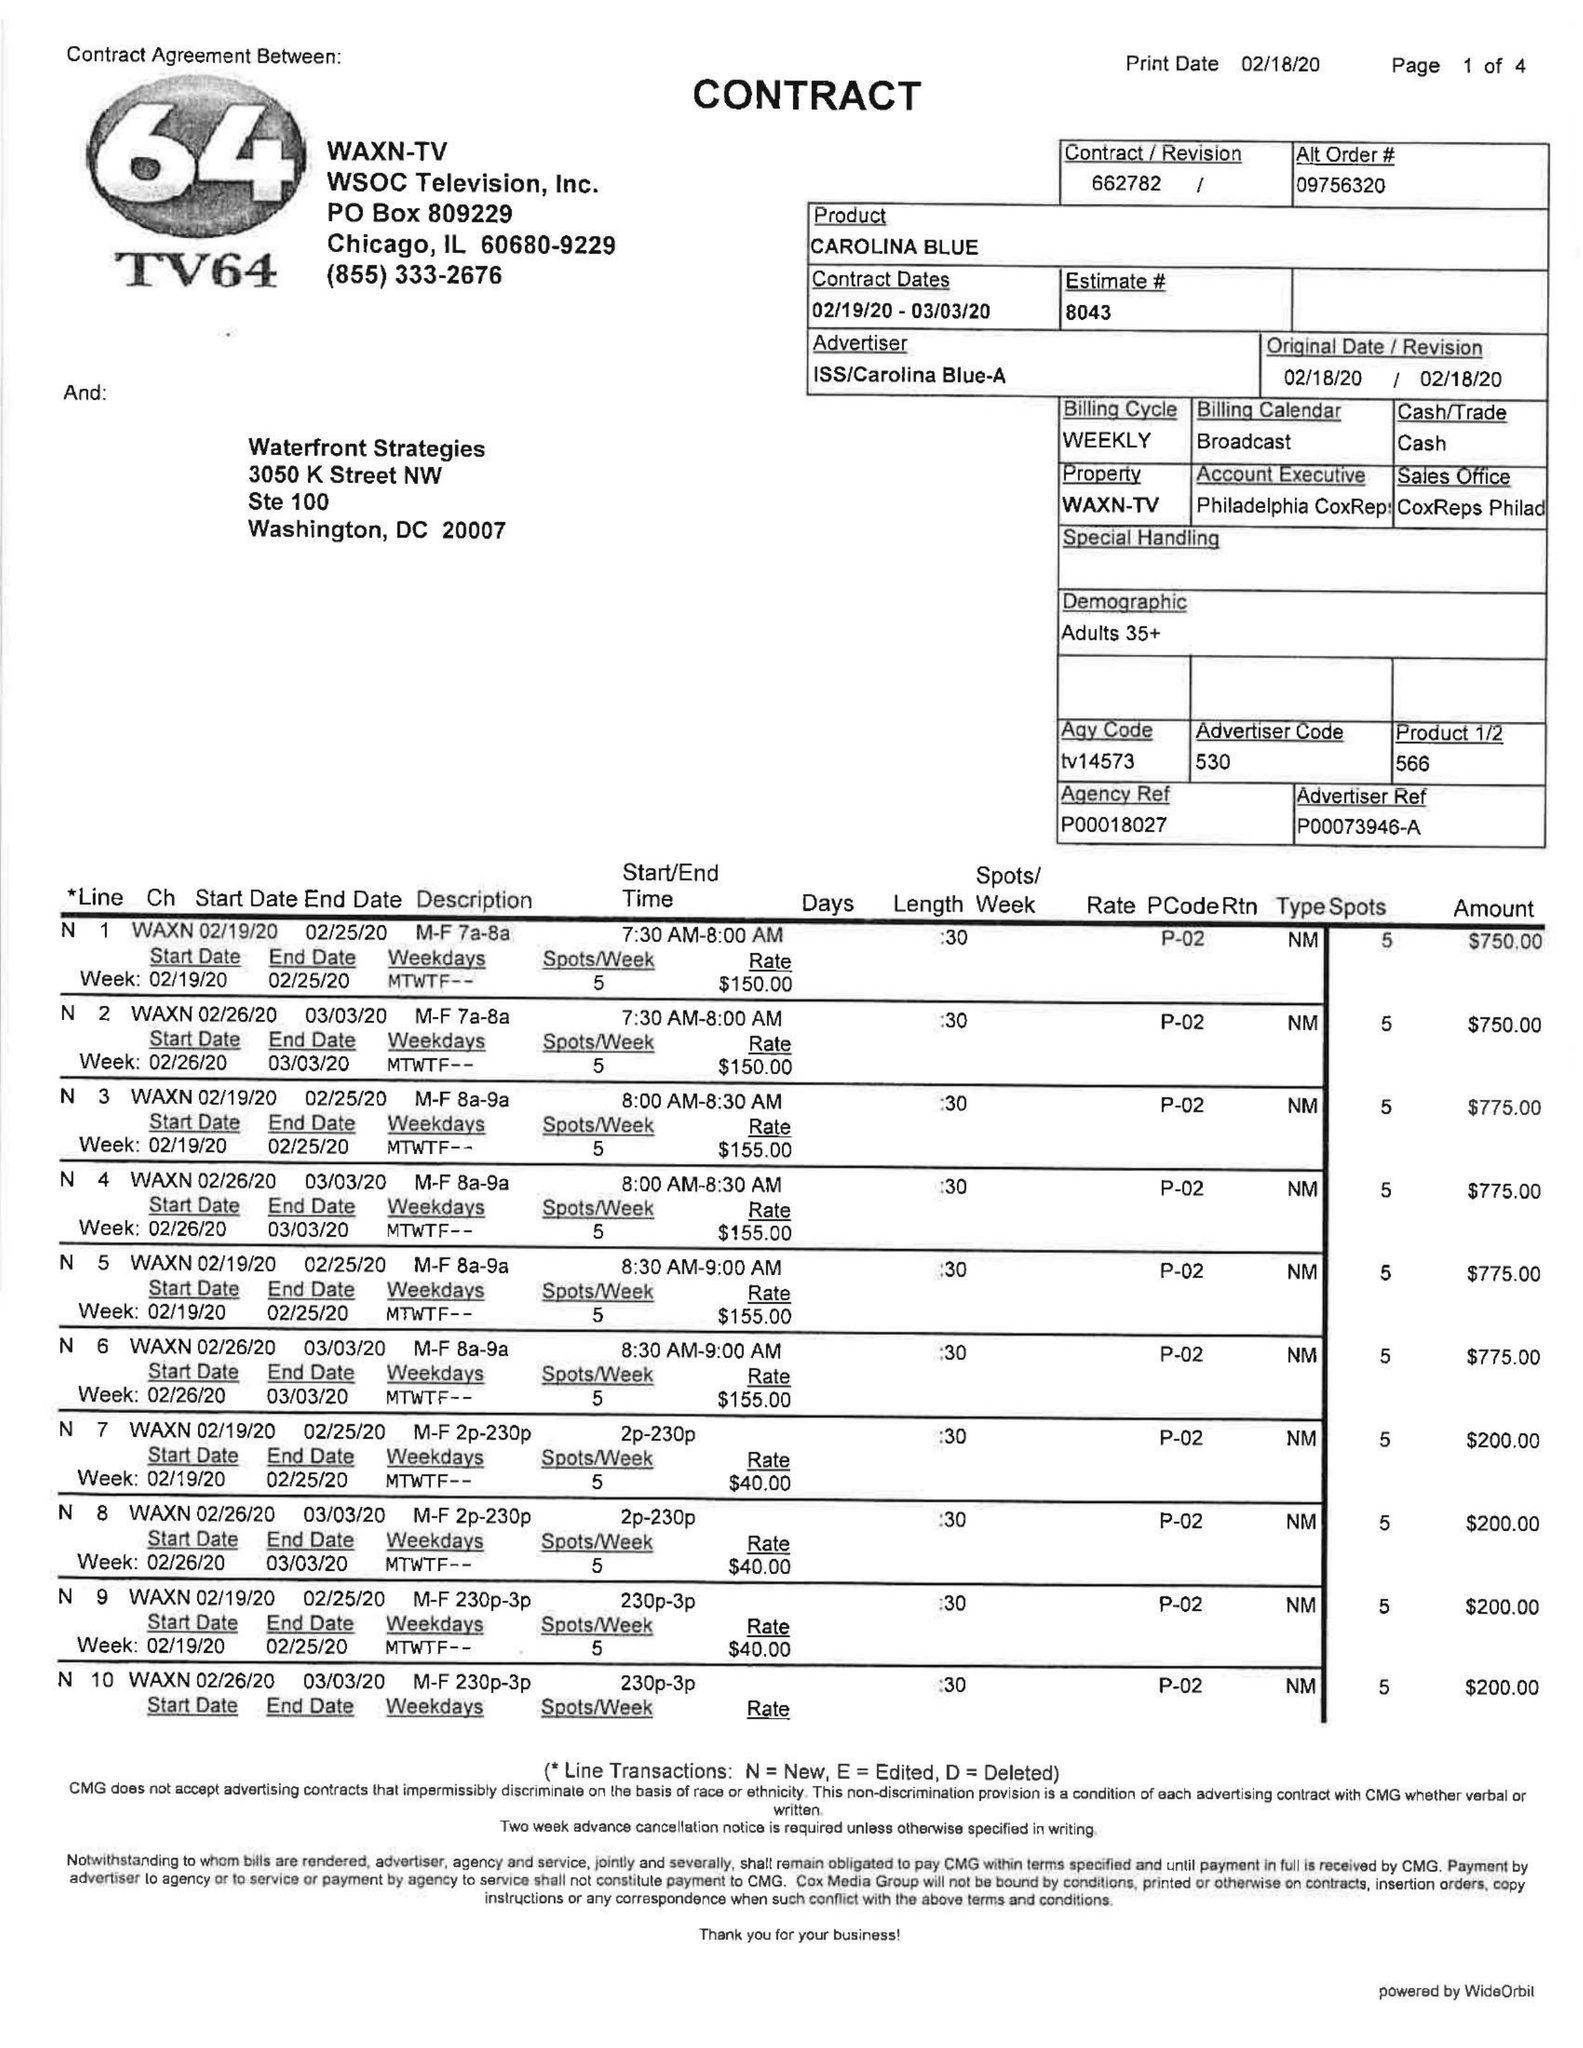What is the value for the contract_num?
Answer the question using a single word or phrase. 662782 